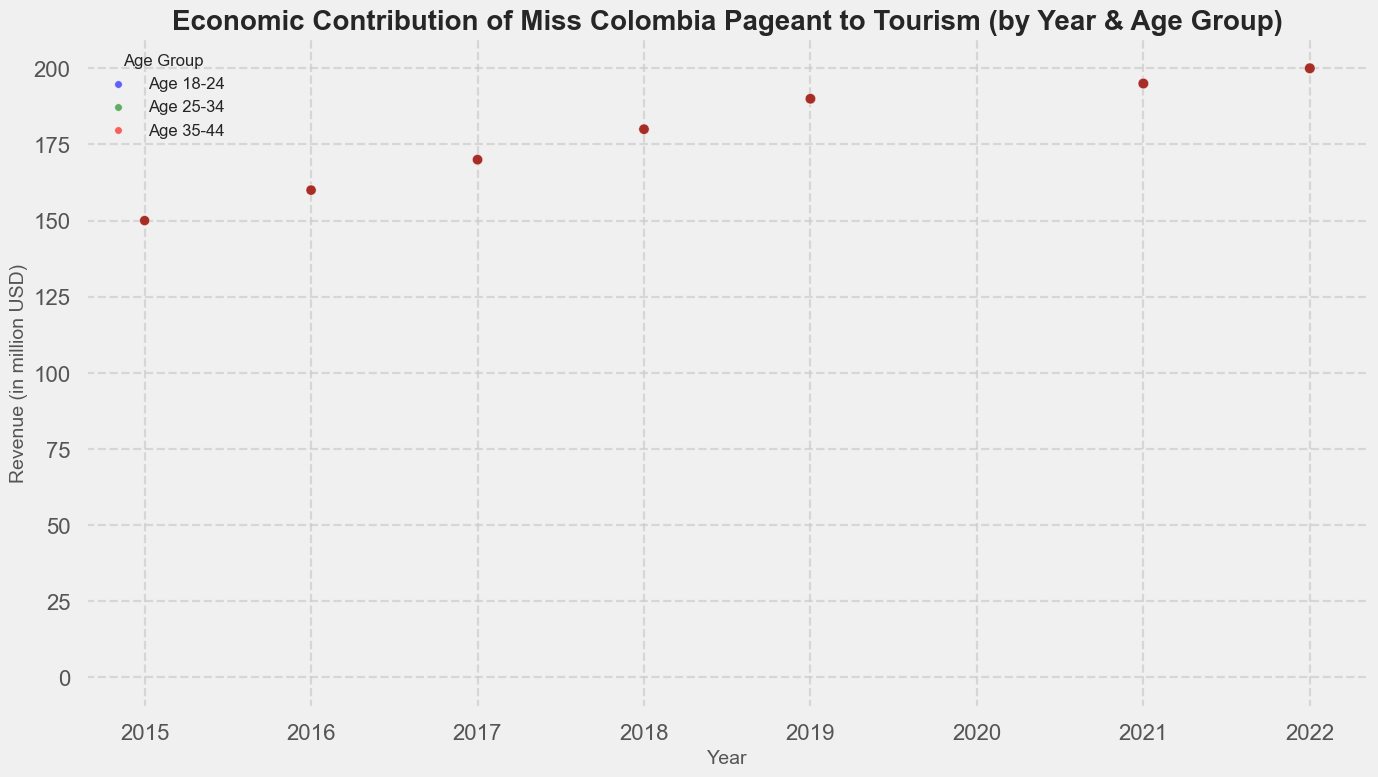What was the difference in revenue between 2016 and 2019 for the Miss Colombia pageant? To find the difference in revenue, look at the revenue data points for the years 2016 and 2019. Revenue in 2016 was $160 million USD, and in 2019 it was $190 million USD. The difference is $190 million - $160 million = $30 million.
Answer: $30 million Which age group had the largest bubble size in 2022? Bubble size represents Tourist Arrivals, and the largest bubbles indicate the largest number of arrivals. In 2022, all age groups (18-24, 25-34, 35-44) have similar bubble sizes, implying similar Tourist Arrivals of 350,000 each.
Answer: All age groups What is the trend in revenue from the Miss Colombia pageant over the years 2015-2022, excluding 2020? Observing the revenue data points over the years reveals a general upward trend from 2015 to 2022, excluding 2020 (which had no revenue due to the pandemic).
Answer: Upward trend In which year did the Miss Colombia pageant have the highest average tourist stay? Look for the highest data point on the y-axis representing “Avg_Stay_Days.” In 2022, the average stay was 9 days, which is the highest in the dataset.
Answer: 2022 Compare the revenue from the Miss Colombia pageant between the age groups 25-34 and 35-44 in 2017. Since revenue is not broken down by age group in the chart and is only represented by year, the revenue for each age group is the same in 2017, which is $170 million USD. Hence, it’s equal for both age groups in 2017.
Answer: Equal Which year had the smallest bubble size and why? The smallest bubble size appears in 2020, indicating the smallest (zero) tourist arrivals due to the pandemic.
Answer: 2020 How did tourist arrivals in 2021 compare to those in 2016? Comparing the bubble sizes for 2016 and 2021, we see that in 2016, tourist arrivals were 300,000, while in 2021, they were 340,000. Thus, tourist arrivals increased in 2021 compared to 2016.
Answer: Increased What is the color of the bubbles representing the age group 35-44? Each age group has a specific color: the age group 35-44 is represented by red bubbles.
Answer: Red Calculate the average revenue from Miss Colombia pageant for the years 2017, 2018, and 2019. Summing the revenues for 2017, 2018, and 2019 gives $170 million + $180 million + $190 million = $540 million. The average revenue is $540 million / 3 = $180 million.
Answer: $180 million Identify the general trend in average stay days for tourists from 2015 to 2022, excluding 2020. Observing the data points for "Avg_Stay_Days," from 2015 to 2022, there is an increasing trend in the average stay days of tourists, rising from 7 days in 2015 to 9 days in 2022.
Answer: Increasing trend 